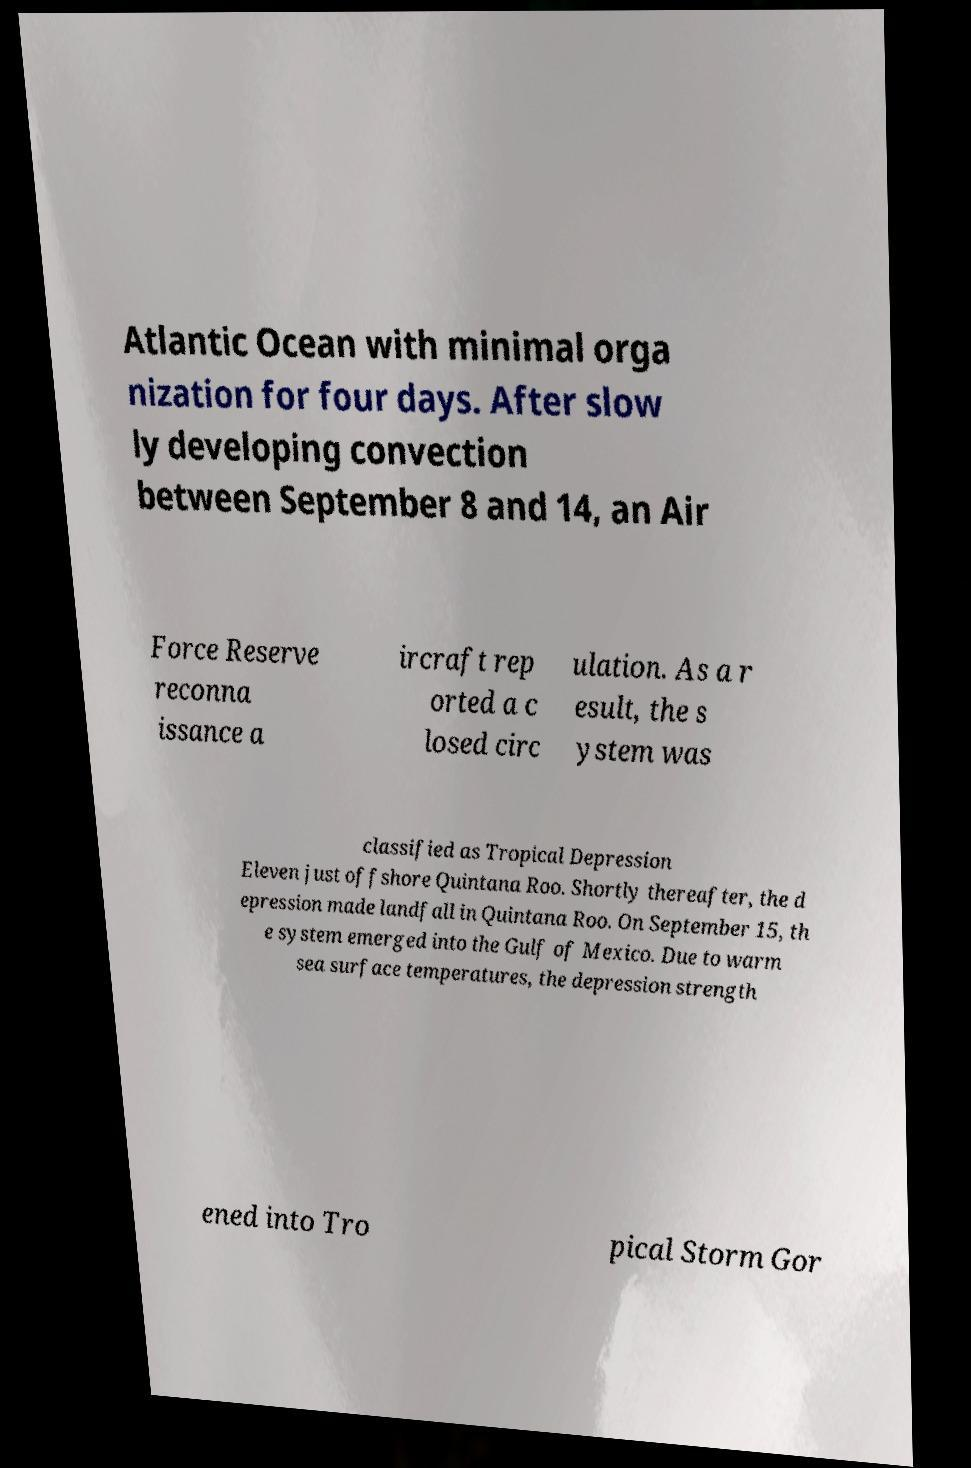Could you assist in decoding the text presented in this image and type it out clearly? Atlantic Ocean with minimal orga nization for four days. After slow ly developing convection between September 8 and 14, an Air Force Reserve reconna issance a ircraft rep orted a c losed circ ulation. As a r esult, the s ystem was classified as Tropical Depression Eleven just offshore Quintana Roo. Shortly thereafter, the d epression made landfall in Quintana Roo. On September 15, th e system emerged into the Gulf of Mexico. Due to warm sea surface temperatures, the depression strength ened into Tro pical Storm Gor 